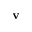Convert formula to latex. <formula><loc_0><loc_0><loc_500><loc_500>v</formula> 